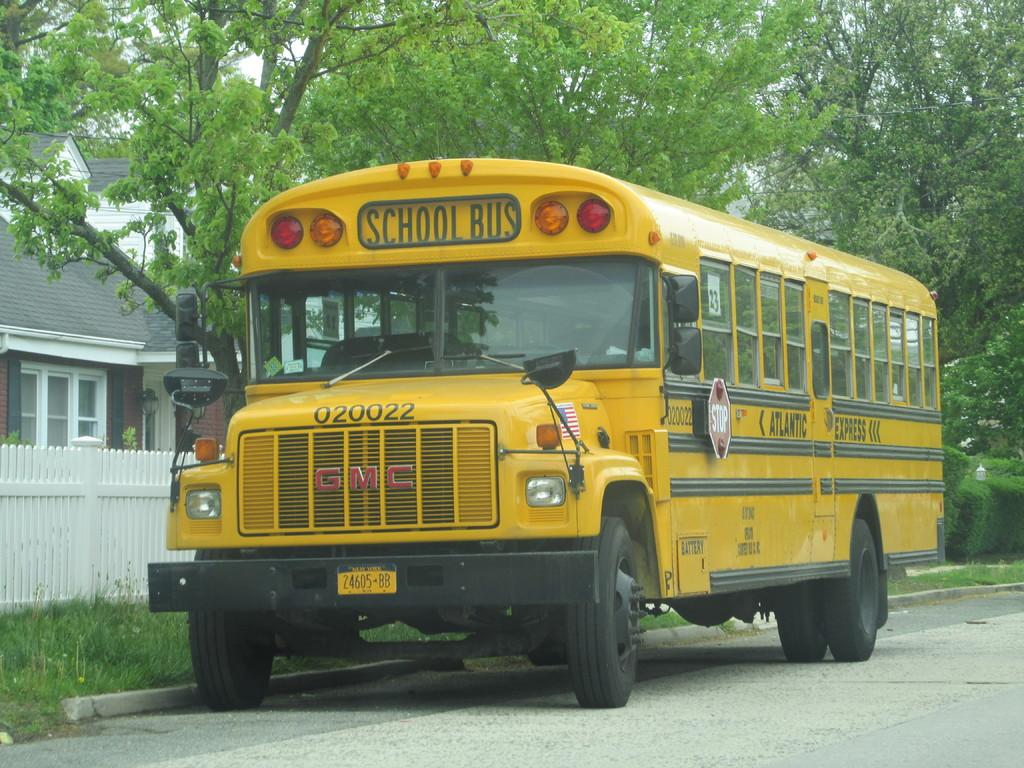What type of vehicle is in the image? There is a yellow bus in the image. What is at the bottom of the image? There is a road at the bottom of the image. What can be seen in the background of the image? There are trees and houses in the background of the image. What is beside the bus in the image? There is a white fencing beside the bus. What season is depicted in the image? The provided facts do not mention any seasonal elements, so it cannot be determined from the image. 